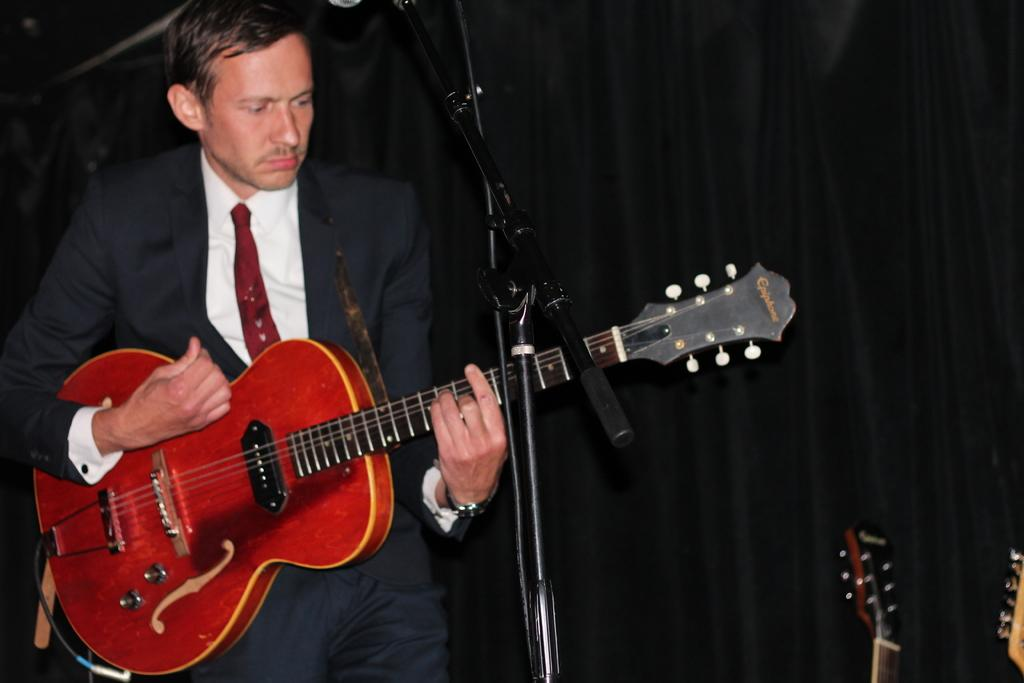What is the main subject of the image? There is a person in the image. What is the person doing in the image? The person is standing in front of a mic and holding a guitar. How many spiders are crawling on the guitar in the image? There are no spiders present in the image, and therefore no spiders are crawling on the guitar. 